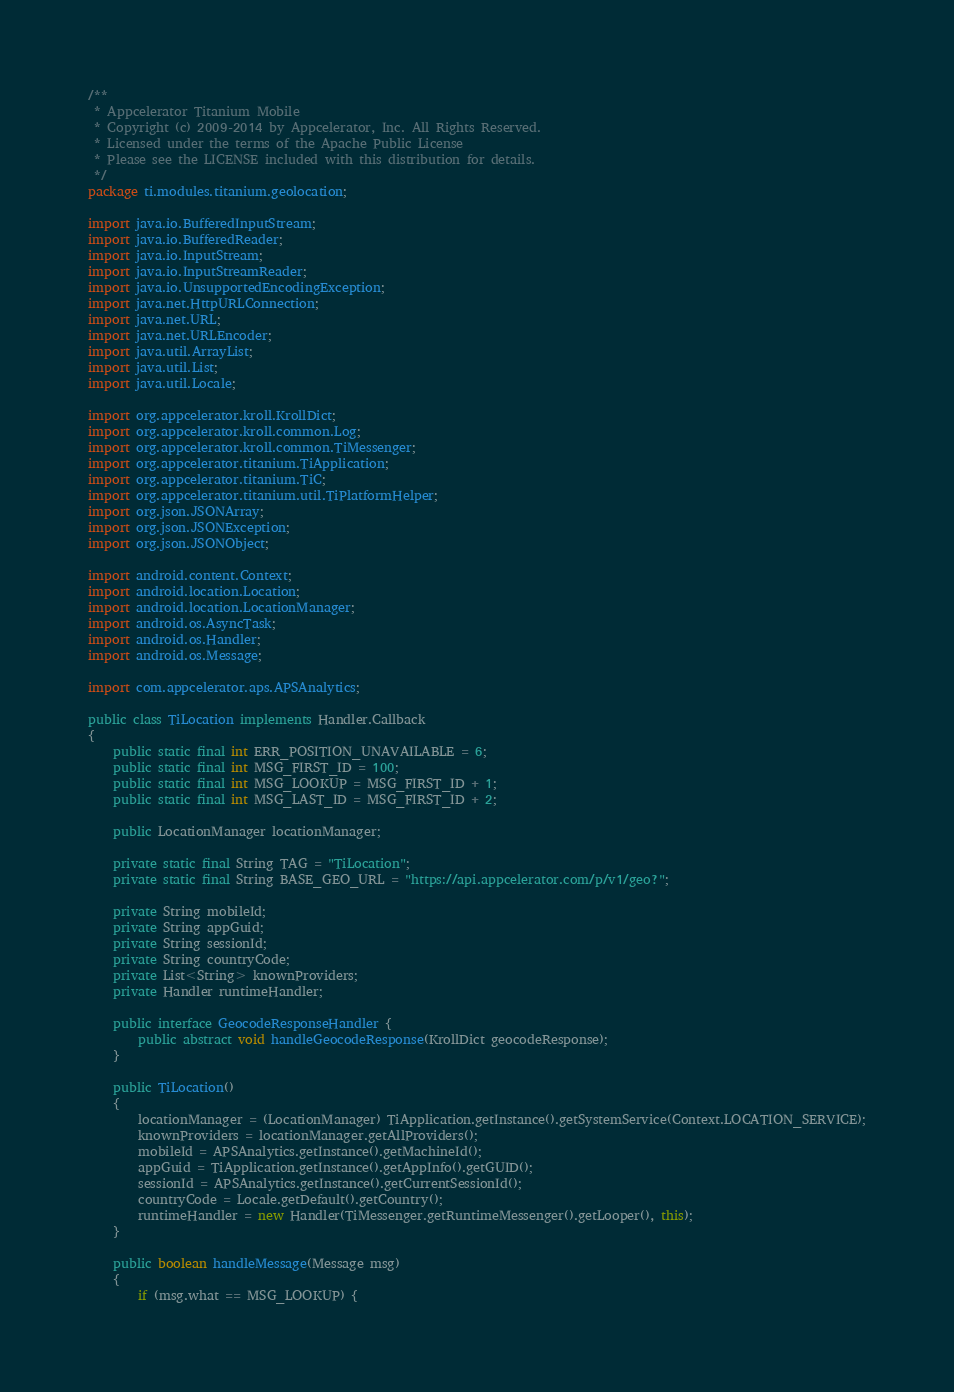Convert code to text. <code><loc_0><loc_0><loc_500><loc_500><_Java_>/**
 * Appcelerator Titanium Mobile
 * Copyright (c) 2009-2014 by Appcelerator, Inc. All Rights Reserved.
 * Licensed under the terms of the Apache Public License
 * Please see the LICENSE included with this distribution for details.
 */
package ti.modules.titanium.geolocation;

import java.io.BufferedInputStream;
import java.io.BufferedReader;
import java.io.InputStream;
import java.io.InputStreamReader;
import java.io.UnsupportedEncodingException;
import java.net.HttpURLConnection;
import java.net.URL;
import java.net.URLEncoder;
import java.util.ArrayList;
import java.util.List;
import java.util.Locale;

import org.appcelerator.kroll.KrollDict;
import org.appcelerator.kroll.common.Log;
import org.appcelerator.kroll.common.TiMessenger;
import org.appcelerator.titanium.TiApplication;
import org.appcelerator.titanium.TiC;
import org.appcelerator.titanium.util.TiPlatformHelper;
import org.json.JSONArray;
import org.json.JSONException;
import org.json.JSONObject;

import android.content.Context;
import android.location.Location;
import android.location.LocationManager;
import android.os.AsyncTask;
import android.os.Handler;
import android.os.Message;

import com.appcelerator.aps.APSAnalytics;

public class TiLocation implements Handler.Callback
{
	public static final int ERR_POSITION_UNAVAILABLE = 6;
	public static final int MSG_FIRST_ID = 100;
	public static final int MSG_LOOKUP = MSG_FIRST_ID + 1;
	public static final int MSG_LAST_ID = MSG_FIRST_ID + 2;

	public LocationManager locationManager;

	private static final String TAG = "TiLocation";
	private static final String BASE_GEO_URL = "https://api.appcelerator.com/p/v1/geo?";

	private String mobileId;
	private String appGuid;
	private String sessionId;
	private String countryCode;
	private List<String> knownProviders;
	private Handler runtimeHandler;

	public interface GeocodeResponseHandler {
		public abstract void handleGeocodeResponse(KrollDict geocodeResponse);
	}

	public TiLocation()
	{
		locationManager = (LocationManager) TiApplication.getInstance().getSystemService(Context.LOCATION_SERVICE);
		knownProviders = locationManager.getAllProviders();
		mobileId = APSAnalytics.getInstance().getMachineId();
		appGuid = TiApplication.getInstance().getAppInfo().getGUID();
		sessionId = APSAnalytics.getInstance().getCurrentSessionId();
		countryCode = Locale.getDefault().getCountry();
		runtimeHandler = new Handler(TiMessenger.getRuntimeMessenger().getLooper(), this);
	}

	public boolean handleMessage(Message msg)
	{
		if (msg.what == MSG_LOOKUP) {</code> 